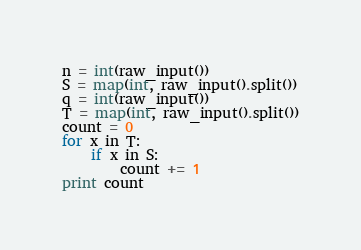Convert code to text. <code><loc_0><loc_0><loc_500><loc_500><_Python_>n = int(raw_input())
S = map(int, raw_input().split())
q = int(raw_input())
T = map(int, raw_input().split())
count = 0
for x in T:
    if x in S:
        count += 1
print count</code> 